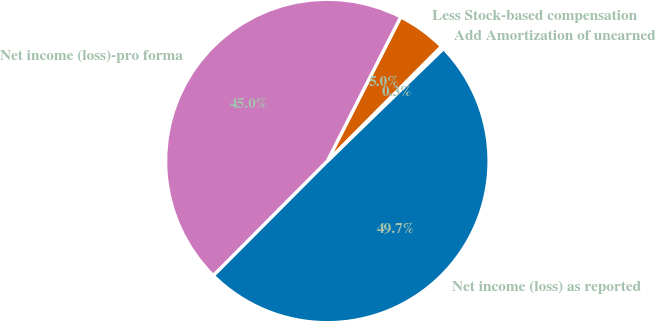Convert chart. <chart><loc_0><loc_0><loc_500><loc_500><pie_chart><fcel>Net income (loss) as reported<fcel>Add Amortization of unearned<fcel>Less Stock-based compensation<fcel>Net income (loss)-pro forma<nl><fcel>49.72%<fcel>0.28%<fcel>4.97%<fcel>45.03%<nl></chart> 